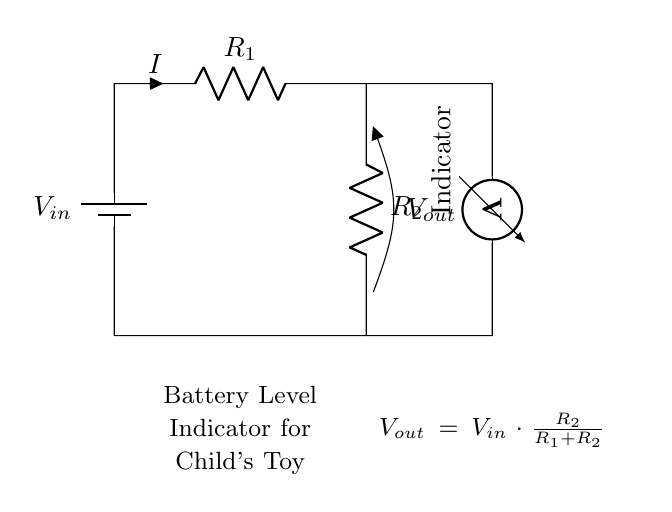What is the input voltage represented as? The input voltage is represented as V in the circuit diagram, indicating the voltage applied to the circuit from the battery.
Answer: V in What do the resistors represent? The resistors R1 and R2 represent the two resistances in the voltage divider. R1 is connected above R2 in the circuit, demonstrating how the resistances affect the output voltage.
Answer: R1 and R2 What is the purpose of the voltmeter? The voltmeter's purpose is to measure the output voltage V out across resistor R2, providing a visual indication of the voltage level in the circuit.
Answer: Battery level indicator What is the output voltage formula? The output voltage formula is shown in the circuit diagram as V out = V in multiplied by the ratio of R2 to the total resistance of R1 plus R2. This represents how the output voltage is derived based on input voltage and resistances.
Answer: V out = V in * R2 / (R1 + R2) How does altering R2 affect V out? Altering R2 changes the output voltage V out based on the voltage divider principle. If R2 increases, V out increases, and if R2 decreases, V out decreases, affecting the voltage level indicated by the voltmeter.
Answer: V out increases with R2 What is the main function of this circuit? The main function of this circuit is to serve as a battery level indicator for a child's electronic toy, allowing users to monitor the battery voltage and determine its charge level.
Answer: Battery level indication 